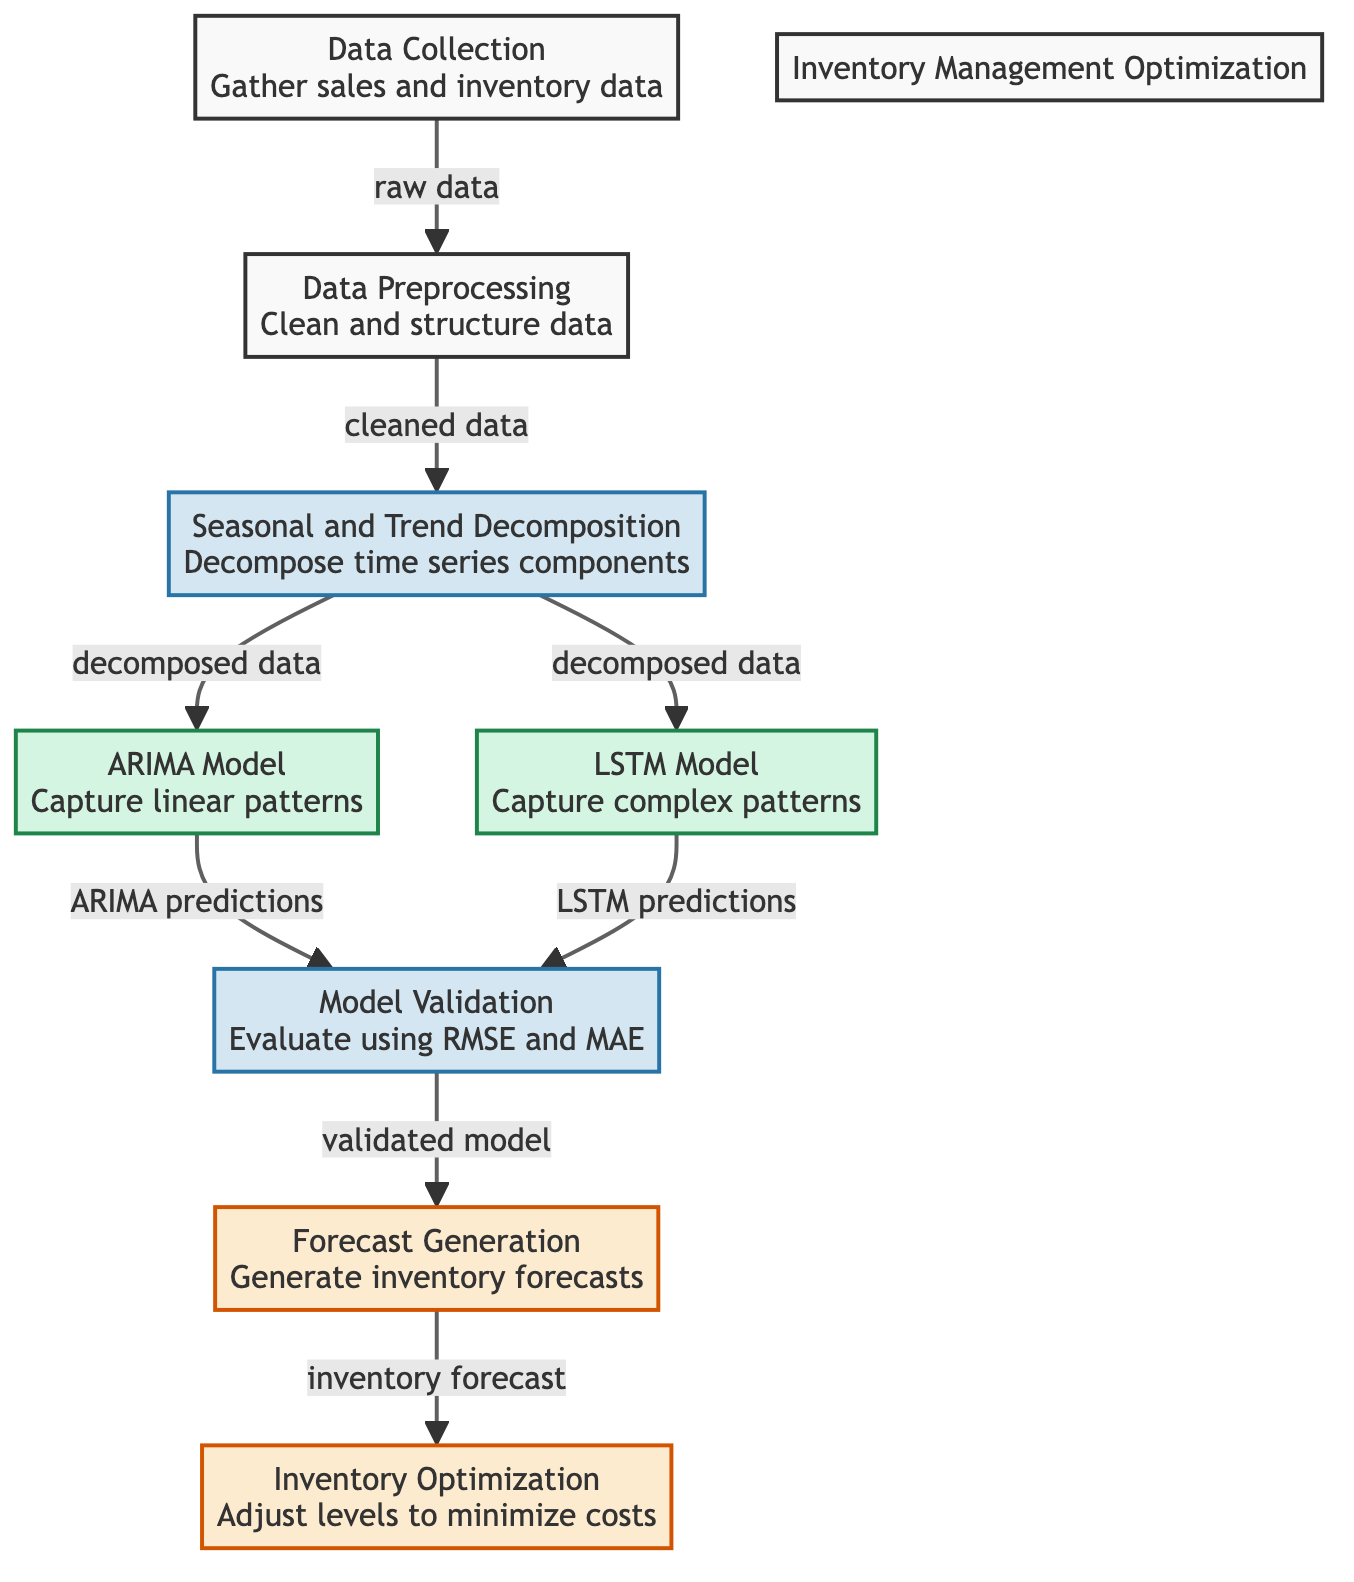What is the first step in the workflow? The first step in the workflow, as indicated in the diagram, is "Data Collection," which involves gathering sales and inventory data.
Answer: Data Collection How many models are used in this diagram? The diagram depicts two models utilized: ARIMA and LSTM, each designed to capture different patterns in the data.
Answer: Two What is the output of the model validation step? The model validation step outputs a "validated model," as shown in the diagram.
Answer: Validated model What is done after seasonal and trend decomposition? After the seasonal and trend decomposition, both the ARIMA model and LSTM model take the decomposed data to generate predictions.
Answer: ARIMA model and LSTM model Which step directly follows forecast generation? The step that directly follows forecast generation is "Inventory Optimization," where inventory levels are adjusted to minimize costs.
Answer: Inventory Optimization From which step does cleaned data come? Cleaned data comes from the "Data Preprocessing" step, which processes the raw data collected initially.
Answer: Data Preprocessing Which model captures linear patterns? The model designed to capture linear patterns, as indicated in the diagram, is the ARIMA model.
Answer: ARIMA Model What is the purpose of model validation? The purpose of model validation is to evaluate the predictions using metrics such as RMSE and MAE to ensure the models' accuracy.
Answer: Evaluate using RMSE and MAE How does the diagram connect data preprocessing and seasonal trend decomposition? The diagram shows a connection from "Data Preprocessing" to "Seasonal and Trend Decomposition," indicating that the output of preprocessing feeds into the decomposition step.
Answer: Connection from Data Preprocessing to Seasonal and Trend Decomposition 